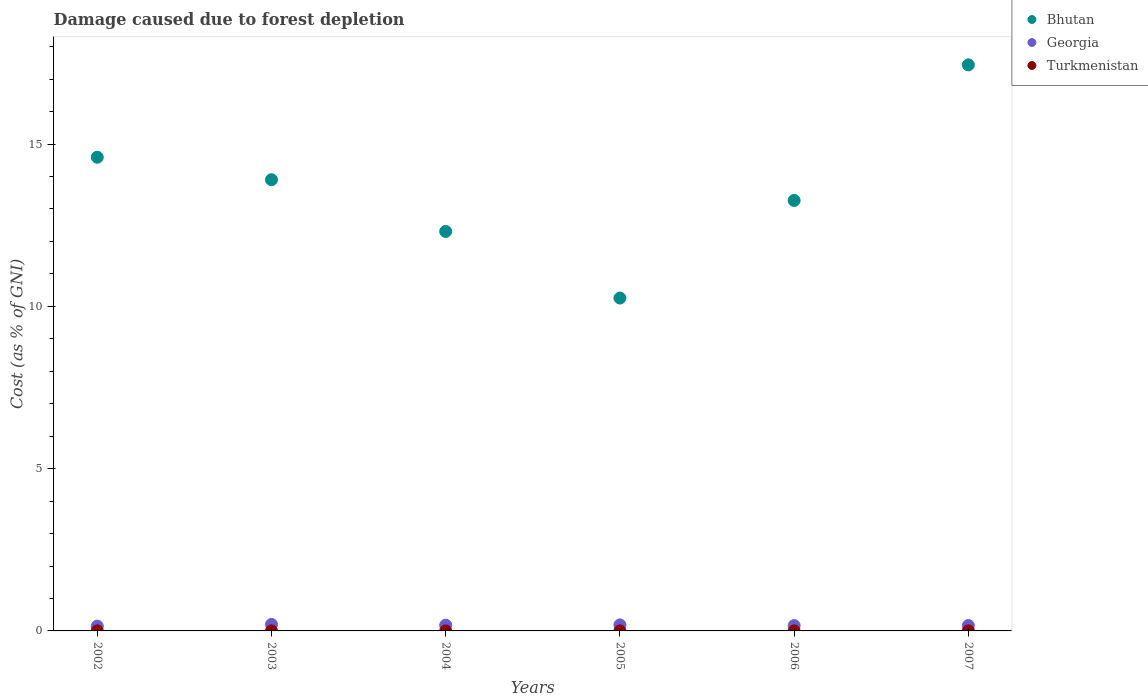How many different coloured dotlines are there?
Offer a terse response. 3. What is the cost of damage caused due to forest depletion in Georgia in 2005?
Keep it short and to the point. 0.19. Across all years, what is the maximum cost of damage caused due to forest depletion in Bhutan?
Ensure brevity in your answer.  17.44. Across all years, what is the minimum cost of damage caused due to forest depletion in Georgia?
Make the answer very short. 0.15. In which year was the cost of damage caused due to forest depletion in Turkmenistan maximum?
Your answer should be compact. 2006. What is the total cost of damage caused due to forest depletion in Georgia in the graph?
Provide a short and direct response. 1.04. What is the difference between the cost of damage caused due to forest depletion in Bhutan in 2003 and that in 2007?
Your response must be concise. -3.54. What is the difference between the cost of damage caused due to forest depletion in Turkmenistan in 2002 and the cost of damage caused due to forest depletion in Georgia in 2003?
Offer a terse response. -0.2. What is the average cost of damage caused due to forest depletion in Georgia per year?
Offer a terse response. 0.17. In the year 2002, what is the difference between the cost of damage caused due to forest depletion in Georgia and cost of damage caused due to forest depletion in Bhutan?
Your answer should be compact. -14.45. What is the ratio of the cost of damage caused due to forest depletion in Turkmenistan in 2002 to that in 2006?
Your answer should be very brief. 0.59. Is the difference between the cost of damage caused due to forest depletion in Georgia in 2003 and 2004 greater than the difference between the cost of damage caused due to forest depletion in Bhutan in 2003 and 2004?
Ensure brevity in your answer.  No. What is the difference between the highest and the second highest cost of damage caused due to forest depletion in Bhutan?
Your answer should be compact. 2.85. What is the difference between the highest and the lowest cost of damage caused due to forest depletion in Bhutan?
Offer a very short reply. 7.18. In how many years, is the cost of damage caused due to forest depletion in Turkmenistan greater than the average cost of damage caused due to forest depletion in Turkmenistan taken over all years?
Keep it short and to the point. 2. Does the cost of damage caused due to forest depletion in Bhutan monotonically increase over the years?
Make the answer very short. No. Is the cost of damage caused due to forest depletion in Georgia strictly greater than the cost of damage caused due to forest depletion in Turkmenistan over the years?
Give a very brief answer. Yes. How many dotlines are there?
Provide a succinct answer. 3. How many years are there in the graph?
Provide a succinct answer. 6. What is the difference between two consecutive major ticks on the Y-axis?
Give a very brief answer. 5. Are the values on the major ticks of Y-axis written in scientific E-notation?
Offer a terse response. No. Does the graph contain any zero values?
Your answer should be very brief. No. Does the graph contain grids?
Make the answer very short. No. How many legend labels are there?
Provide a short and direct response. 3. What is the title of the graph?
Provide a succinct answer. Damage caused due to forest depletion. Does "Cayman Islands" appear as one of the legend labels in the graph?
Provide a succinct answer. No. What is the label or title of the Y-axis?
Offer a very short reply. Cost (as % of GNI). What is the Cost (as % of GNI) of Bhutan in 2002?
Keep it short and to the point. 14.59. What is the Cost (as % of GNI) of Georgia in 2002?
Provide a short and direct response. 0.15. What is the Cost (as % of GNI) of Turkmenistan in 2002?
Offer a terse response. 0. What is the Cost (as % of GNI) of Bhutan in 2003?
Your answer should be compact. 13.9. What is the Cost (as % of GNI) of Georgia in 2003?
Keep it short and to the point. 0.2. What is the Cost (as % of GNI) in Turkmenistan in 2003?
Offer a terse response. 0. What is the Cost (as % of GNI) in Bhutan in 2004?
Ensure brevity in your answer.  12.31. What is the Cost (as % of GNI) in Georgia in 2004?
Provide a succinct answer. 0.18. What is the Cost (as % of GNI) of Turkmenistan in 2004?
Make the answer very short. 0. What is the Cost (as % of GNI) in Bhutan in 2005?
Your answer should be very brief. 10.26. What is the Cost (as % of GNI) of Georgia in 2005?
Offer a terse response. 0.19. What is the Cost (as % of GNI) of Turkmenistan in 2005?
Provide a short and direct response. 0. What is the Cost (as % of GNI) in Bhutan in 2006?
Offer a terse response. 13.26. What is the Cost (as % of GNI) of Georgia in 2006?
Your answer should be very brief. 0.16. What is the Cost (as % of GNI) in Turkmenistan in 2006?
Make the answer very short. 0. What is the Cost (as % of GNI) of Bhutan in 2007?
Provide a short and direct response. 17.44. What is the Cost (as % of GNI) of Georgia in 2007?
Offer a very short reply. 0.17. What is the Cost (as % of GNI) in Turkmenistan in 2007?
Your answer should be very brief. 0. Across all years, what is the maximum Cost (as % of GNI) of Bhutan?
Your answer should be very brief. 17.44. Across all years, what is the maximum Cost (as % of GNI) of Georgia?
Provide a succinct answer. 0.2. Across all years, what is the maximum Cost (as % of GNI) in Turkmenistan?
Provide a succinct answer. 0. Across all years, what is the minimum Cost (as % of GNI) of Bhutan?
Offer a terse response. 10.26. Across all years, what is the minimum Cost (as % of GNI) of Georgia?
Offer a terse response. 0.15. Across all years, what is the minimum Cost (as % of GNI) in Turkmenistan?
Your answer should be very brief. 0. What is the total Cost (as % of GNI) in Bhutan in the graph?
Provide a short and direct response. 81.76. What is the total Cost (as % of GNI) in Georgia in the graph?
Keep it short and to the point. 1.04. What is the total Cost (as % of GNI) of Turkmenistan in the graph?
Your response must be concise. 0.01. What is the difference between the Cost (as % of GNI) in Bhutan in 2002 and that in 2003?
Offer a very short reply. 0.69. What is the difference between the Cost (as % of GNI) of Georgia in 2002 and that in 2003?
Provide a succinct answer. -0.05. What is the difference between the Cost (as % of GNI) of Turkmenistan in 2002 and that in 2003?
Offer a very short reply. 0. What is the difference between the Cost (as % of GNI) of Bhutan in 2002 and that in 2004?
Give a very brief answer. 2.29. What is the difference between the Cost (as % of GNI) in Georgia in 2002 and that in 2004?
Ensure brevity in your answer.  -0.03. What is the difference between the Cost (as % of GNI) in Bhutan in 2002 and that in 2005?
Provide a succinct answer. 4.34. What is the difference between the Cost (as % of GNI) of Georgia in 2002 and that in 2005?
Your answer should be compact. -0.04. What is the difference between the Cost (as % of GNI) in Turkmenistan in 2002 and that in 2005?
Ensure brevity in your answer.  0. What is the difference between the Cost (as % of GNI) of Bhutan in 2002 and that in 2006?
Make the answer very short. 1.33. What is the difference between the Cost (as % of GNI) in Georgia in 2002 and that in 2006?
Your answer should be very brief. -0.02. What is the difference between the Cost (as % of GNI) of Turkmenistan in 2002 and that in 2006?
Keep it short and to the point. -0. What is the difference between the Cost (as % of GNI) in Bhutan in 2002 and that in 2007?
Ensure brevity in your answer.  -2.85. What is the difference between the Cost (as % of GNI) of Georgia in 2002 and that in 2007?
Offer a very short reply. -0.02. What is the difference between the Cost (as % of GNI) in Turkmenistan in 2002 and that in 2007?
Your answer should be very brief. -0. What is the difference between the Cost (as % of GNI) of Bhutan in 2003 and that in 2004?
Give a very brief answer. 1.59. What is the difference between the Cost (as % of GNI) of Georgia in 2003 and that in 2004?
Make the answer very short. 0.02. What is the difference between the Cost (as % of GNI) of Bhutan in 2003 and that in 2005?
Your answer should be compact. 3.65. What is the difference between the Cost (as % of GNI) in Georgia in 2003 and that in 2005?
Ensure brevity in your answer.  0.01. What is the difference between the Cost (as % of GNI) of Turkmenistan in 2003 and that in 2005?
Offer a terse response. 0. What is the difference between the Cost (as % of GNI) in Bhutan in 2003 and that in 2006?
Provide a succinct answer. 0.64. What is the difference between the Cost (as % of GNI) in Georgia in 2003 and that in 2006?
Provide a succinct answer. 0.04. What is the difference between the Cost (as % of GNI) of Turkmenistan in 2003 and that in 2006?
Your answer should be compact. -0. What is the difference between the Cost (as % of GNI) in Bhutan in 2003 and that in 2007?
Give a very brief answer. -3.54. What is the difference between the Cost (as % of GNI) in Georgia in 2003 and that in 2007?
Provide a short and direct response. 0.03. What is the difference between the Cost (as % of GNI) of Turkmenistan in 2003 and that in 2007?
Ensure brevity in your answer.  -0. What is the difference between the Cost (as % of GNI) of Bhutan in 2004 and that in 2005?
Offer a terse response. 2.05. What is the difference between the Cost (as % of GNI) of Georgia in 2004 and that in 2005?
Keep it short and to the point. -0.01. What is the difference between the Cost (as % of GNI) in Bhutan in 2004 and that in 2006?
Keep it short and to the point. -0.95. What is the difference between the Cost (as % of GNI) of Georgia in 2004 and that in 2006?
Provide a short and direct response. 0.01. What is the difference between the Cost (as % of GNI) in Turkmenistan in 2004 and that in 2006?
Keep it short and to the point. -0. What is the difference between the Cost (as % of GNI) in Bhutan in 2004 and that in 2007?
Offer a very short reply. -5.13. What is the difference between the Cost (as % of GNI) in Georgia in 2004 and that in 2007?
Your response must be concise. 0.01. What is the difference between the Cost (as % of GNI) of Turkmenistan in 2004 and that in 2007?
Your answer should be compact. -0. What is the difference between the Cost (as % of GNI) in Bhutan in 2005 and that in 2006?
Provide a short and direct response. -3.01. What is the difference between the Cost (as % of GNI) of Georgia in 2005 and that in 2006?
Ensure brevity in your answer.  0.02. What is the difference between the Cost (as % of GNI) in Turkmenistan in 2005 and that in 2006?
Provide a short and direct response. -0. What is the difference between the Cost (as % of GNI) in Bhutan in 2005 and that in 2007?
Give a very brief answer. -7.18. What is the difference between the Cost (as % of GNI) in Georgia in 2005 and that in 2007?
Provide a short and direct response. 0.02. What is the difference between the Cost (as % of GNI) of Turkmenistan in 2005 and that in 2007?
Give a very brief answer. -0. What is the difference between the Cost (as % of GNI) in Bhutan in 2006 and that in 2007?
Your answer should be very brief. -4.18. What is the difference between the Cost (as % of GNI) of Georgia in 2006 and that in 2007?
Provide a short and direct response. -0. What is the difference between the Cost (as % of GNI) in Bhutan in 2002 and the Cost (as % of GNI) in Georgia in 2003?
Your answer should be compact. 14.39. What is the difference between the Cost (as % of GNI) in Bhutan in 2002 and the Cost (as % of GNI) in Turkmenistan in 2003?
Make the answer very short. 14.59. What is the difference between the Cost (as % of GNI) of Georgia in 2002 and the Cost (as % of GNI) of Turkmenistan in 2003?
Your response must be concise. 0.15. What is the difference between the Cost (as % of GNI) of Bhutan in 2002 and the Cost (as % of GNI) of Georgia in 2004?
Ensure brevity in your answer.  14.42. What is the difference between the Cost (as % of GNI) of Bhutan in 2002 and the Cost (as % of GNI) of Turkmenistan in 2004?
Your answer should be compact. 14.59. What is the difference between the Cost (as % of GNI) in Georgia in 2002 and the Cost (as % of GNI) in Turkmenistan in 2004?
Your answer should be compact. 0.15. What is the difference between the Cost (as % of GNI) in Bhutan in 2002 and the Cost (as % of GNI) in Georgia in 2005?
Offer a very short reply. 14.41. What is the difference between the Cost (as % of GNI) in Bhutan in 2002 and the Cost (as % of GNI) in Turkmenistan in 2005?
Offer a very short reply. 14.59. What is the difference between the Cost (as % of GNI) of Georgia in 2002 and the Cost (as % of GNI) of Turkmenistan in 2005?
Your response must be concise. 0.15. What is the difference between the Cost (as % of GNI) in Bhutan in 2002 and the Cost (as % of GNI) in Georgia in 2006?
Give a very brief answer. 14.43. What is the difference between the Cost (as % of GNI) of Bhutan in 2002 and the Cost (as % of GNI) of Turkmenistan in 2006?
Keep it short and to the point. 14.59. What is the difference between the Cost (as % of GNI) in Georgia in 2002 and the Cost (as % of GNI) in Turkmenistan in 2006?
Your response must be concise. 0.15. What is the difference between the Cost (as % of GNI) of Bhutan in 2002 and the Cost (as % of GNI) of Georgia in 2007?
Offer a terse response. 14.43. What is the difference between the Cost (as % of GNI) in Bhutan in 2002 and the Cost (as % of GNI) in Turkmenistan in 2007?
Provide a succinct answer. 14.59. What is the difference between the Cost (as % of GNI) of Georgia in 2002 and the Cost (as % of GNI) of Turkmenistan in 2007?
Your answer should be very brief. 0.15. What is the difference between the Cost (as % of GNI) in Bhutan in 2003 and the Cost (as % of GNI) in Georgia in 2004?
Your answer should be very brief. 13.72. What is the difference between the Cost (as % of GNI) in Bhutan in 2003 and the Cost (as % of GNI) in Turkmenistan in 2004?
Offer a terse response. 13.9. What is the difference between the Cost (as % of GNI) in Bhutan in 2003 and the Cost (as % of GNI) in Georgia in 2005?
Make the answer very short. 13.72. What is the difference between the Cost (as % of GNI) in Bhutan in 2003 and the Cost (as % of GNI) in Turkmenistan in 2005?
Your answer should be very brief. 13.9. What is the difference between the Cost (as % of GNI) of Georgia in 2003 and the Cost (as % of GNI) of Turkmenistan in 2005?
Your response must be concise. 0.2. What is the difference between the Cost (as % of GNI) in Bhutan in 2003 and the Cost (as % of GNI) in Georgia in 2006?
Provide a succinct answer. 13.74. What is the difference between the Cost (as % of GNI) in Bhutan in 2003 and the Cost (as % of GNI) in Turkmenistan in 2006?
Offer a terse response. 13.9. What is the difference between the Cost (as % of GNI) in Georgia in 2003 and the Cost (as % of GNI) in Turkmenistan in 2006?
Give a very brief answer. 0.2. What is the difference between the Cost (as % of GNI) of Bhutan in 2003 and the Cost (as % of GNI) of Georgia in 2007?
Give a very brief answer. 13.74. What is the difference between the Cost (as % of GNI) of Bhutan in 2003 and the Cost (as % of GNI) of Turkmenistan in 2007?
Your response must be concise. 13.9. What is the difference between the Cost (as % of GNI) of Georgia in 2003 and the Cost (as % of GNI) of Turkmenistan in 2007?
Your answer should be compact. 0.2. What is the difference between the Cost (as % of GNI) in Bhutan in 2004 and the Cost (as % of GNI) in Georgia in 2005?
Provide a short and direct response. 12.12. What is the difference between the Cost (as % of GNI) of Bhutan in 2004 and the Cost (as % of GNI) of Turkmenistan in 2005?
Ensure brevity in your answer.  12.31. What is the difference between the Cost (as % of GNI) of Georgia in 2004 and the Cost (as % of GNI) of Turkmenistan in 2005?
Offer a terse response. 0.18. What is the difference between the Cost (as % of GNI) of Bhutan in 2004 and the Cost (as % of GNI) of Georgia in 2006?
Provide a short and direct response. 12.14. What is the difference between the Cost (as % of GNI) of Bhutan in 2004 and the Cost (as % of GNI) of Turkmenistan in 2006?
Ensure brevity in your answer.  12.31. What is the difference between the Cost (as % of GNI) in Georgia in 2004 and the Cost (as % of GNI) in Turkmenistan in 2006?
Provide a succinct answer. 0.18. What is the difference between the Cost (as % of GNI) of Bhutan in 2004 and the Cost (as % of GNI) of Georgia in 2007?
Your response must be concise. 12.14. What is the difference between the Cost (as % of GNI) in Bhutan in 2004 and the Cost (as % of GNI) in Turkmenistan in 2007?
Your answer should be very brief. 12.31. What is the difference between the Cost (as % of GNI) in Georgia in 2004 and the Cost (as % of GNI) in Turkmenistan in 2007?
Your answer should be very brief. 0.18. What is the difference between the Cost (as % of GNI) of Bhutan in 2005 and the Cost (as % of GNI) of Georgia in 2006?
Offer a very short reply. 10.09. What is the difference between the Cost (as % of GNI) of Bhutan in 2005 and the Cost (as % of GNI) of Turkmenistan in 2006?
Your answer should be compact. 10.25. What is the difference between the Cost (as % of GNI) of Georgia in 2005 and the Cost (as % of GNI) of Turkmenistan in 2006?
Ensure brevity in your answer.  0.18. What is the difference between the Cost (as % of GNI) of Bhutan in 2005 and the Cost (as % of GNI) of Georgia in 2007?
Offer a very short reply. 10.09. What is the difference between the Cost (as % of GNI) in Bhutan in 2005 and the Cost (as % of GNI) in Turkmenistan in 2007?
Provide a succinct answer. 10.25. What is the difference between the Cost (as % of GNI) of Georgia in 2005 and the Cost (as % of GNI) of Turkmenistan in 2007?
Provide a short and direct response. 0.18. What is the difference between the Cost (as % of GNI) in Bhutan in 2006 and the Cost (as % of GNI) in Georgia in 2007?
Offer a terse response. 13.1. What is the difference between the Cost (as % of GNI) of Bhutan in 2006 and the Cost (as % of GNI) of Turkmenistan in 2007?
Offer a terse response. 13.26. What is the difference between the Cost (as % of GNI) of Georgia in 2006 and the Cost (as % of GNI) of Turkmenistan in 2007?
Ensure brevity in your answer.  0.16. What is the average Cost (as % of GNI) of Bhutan per year?
Offer a terse response. 13.63. What is the average Cost (as % of GNI) of Georgia per year?
Your response must be concise. 0.17. What is the average Cost (as % of GNI) in Turkmenistan per year?
Provide a succinct answer. 0. In the year 2002, what is the difference between the Cost (as % of GNI) in Bhutan and Cost (as % of GNI) in Georgia?
Ensure brevity in your answer.  14.45. In the year 2002, what is the difference between the Cost (as % of GNI) in Bhutan and Cost (as % of GNI) in Turkmenistan?
Ensure brevity in your answer.  14.59. In the year 2002, what is the difference between the Cost (as % of GNI) in Georgia and Cost (as % of GNI) in Turkmenistan?
Give a very brief answer. 0.15. In the year 2003, what is the difference between the Cost (as % of GNI) of Bhutan and Cost (as % of GNI) of Georgia?
Your response must be concise. 13.7. In the year 2003, what is the difference between the Cost (as % of GNI) in Bhutan and Cost (as % of GNI) in Turkmenistan?
Provide a short and direct response. 13.9. In the year 2003, what is the difference between the Cost (as % of GNI) of Georgia and Cost (as % of GNI) of Turkmenistan?
Ensure brevity in your answer.  0.2. In the year 2004, what is the difference between the Cost (as % of GNI) of Bhutan and Cost (as % of GNI) of Georgia?
Make the answer very short. 12.13. In the year 2004, what is the difference between the Cost (as % of GNI) in Bhutan and Cost (as % of GNI) in Turkmenistan?
Ensure brevity in your answer.  12.31. In the year 2004, what is the difference between the Cost (as % of GNI) in Georgia and Cost (as % of GNI) in Turkmenistan?
Keep it short and to the point. 0.18. In the year 2005, what is the difference between the Cost (as % of GNI) in Bhutan and Cost (as % of GNI) in Georgia?
Give a very brief answer. 10.07. In the year 2005, what is the difference between the Cost (as % of GNI) of Bhutan and Cost (as % of GNI) of Turkmenistan?
Your response must be concise. 10.26. In the year 2005, what is the difference between the Cost (as % of GNI) of Georgia and Cost (as % of GNI) of Turkmenistan?
Keep it short and to the point. 0.19. In the year 2006, what is the difference between the Cost (as % of GNI) in Bhutan and Cost (as % of GNI) in Georgia?
Ensure brevity in your answer.  13.1. In the year 2006, what is the difference between the Cost (as % of GNI) of Bhutan and Cost (as % of GNI) of Turkmenistan?
Keep it short and to the point. 13.26. In the year 2006, what is the difference between the Cost (as % of GNI) in Georgia and Cost (as % of GNI) in Turkmenistan?
Offer a very short reply. 0.16. In the year 2007, what is the difference between the Cost (as % of GNI) in Bhutan and Cost (as % of GNI) in Georgia?
Provide a short and direct response. 17.27. In the year 2007, what is the difference between the Cost (as % of GNI) of Bhutan and Cost (as % of GNI) of Turkmenistan?
Provide a short and direct response. 17.44. In the year 2007, what is the difference between the Cost (as % of GNI) of Georgia and Cost (as % of GNI) of Turkmenistan?
Your answer should be compact. 0.16. What is the ratio of the Cost (as % of GNI) in Bhutan in 2002 to that in 2003?
Make the answer very short. 1.05. What is the ratio of the Cost (as % of GNI) of Georgia in 2002 to that in 2003?
Provide a succinct answer. 0.74. What is the ratio of the Cost (as % of GNI) in Turkmenistan in 2002 to that in 2003?
Your response must be concise. 1.02. What is the ratio of the Cost (as % of GNI) of Bhutan in 2002 to that in 2004?
Make the answer very short. 1.19. What is the ratio of the Cost (as % of GNI) of Georgia in 2002 to that in 2004?
Offer a terse response. 0.83. What is the ratio of the Cost (as % of GNI) of Turkmenistan in 2002 to that in 2004?
Offer a very short reply. 1.33. What is the ratio of the Cost (as % of GNI) of Bhutan in 2002 to that in 2005?
Provide a short and direct response. 1.42. What is the ratio of the Cost (as % of GNI) of Georgia in 2002 to that in 2005?
Your answer should be compact. 0.8. What is the ratio of the Cost (as % of GNI) in Turkmenistan in 2002 to that in 2005?
Ensure brevity in your answer.  1.41. What is the ratio of the Cost (as % of GNI) of Bhutan in 2002 to that in 2006?
Give a very brief answer. 1.1. What is the ratio of the Cost (as % of GNI) of Georgia in 2002 to that in 2006?
Provide a succinct answer. 0.91. What is the ratio of the Cost (as % of GNI) of Turkmenistan in 2002 to that in 2006?
Provide a succinct answer. 0.59. What is the ratio of the Cost (as % of GNI) of Bhutan in 2002 to that in 2007?
Your answer should be compact. 0.84. What is the ratio of the Cost (as % of GNI) in Georgia in 2002 to that in 2007?
Make the answer very short. 0.89. What is the ratio of the Cost (as % of GNI) of Turkmenistan in 2002 to that in 2007?
Provide a short and direct response. 0.63. What is the ratio of the Cost (as % of GNI) in Bhutan in 2003 to that in 2004?
Your answer should be very brief. 1.13. What is the ratio of the Cost (as % of GNI) of Georgia in 2003 to that in 2004?
Your answer should be very brief. 1.13. What is the ratio of the Cost (as % of GNI) in Turkmenistan in 2003 to that in 2004?
Provide a short and direct response. 1.3. What is the ratio of the Cost (as % of GNI) of Bhutan in 2003 to that in 2005?
Make the answer very short. 1.36. What is the ratio of the Cost (as % of GNI) in Georgia in 2003 to that in 2005?
Your answer should be compact. 1.08. What is the ratio of the Cost (as % of GNI) of Turkmenistan in 2003 to that in 2005?
Give a very brief answer. 1.37. What is the ratio of the Cost (as % of GNI) of Bhutan in 2003 to that in 2006?
Offer a very short reply. 1.05. What is the ratio of the Cost (as % of GNI) in Georgia in 2003 to that in 2006?
Ensure brevity in your answer.  1.23. What is the ratio of the Cost (as % of GNI) in Turkmenistan in 2003 to that in 2006?
Provide a short and direct response. 0.58. What is the ratio of the Cost (as % of GNI) of Bhutan in 2003 to that in 2007?
Offer a terse response. 0.8. What is the ratio of the Cost (as % of GNI) in Georgia in 2003 to that in 2007?
Offer a very short reply. 1.21. What is the ratio of the Cost (as % of GNI) in Turkmenistan in 2003 to that in 2007?
Give a very brief answer. 0.62. What is the ratio of the Cost (as % of GNI) in Bhutan in 2004 to that in 2005?
Offer a very short reply. 1.2. What is the ratio of the Cost (as % of GNI) of Georgia in 2004 to that in 2005?
Your answer should be compact. 0.96. What is the ratio of the Cost (as % of GNI) in Turkmenistan in 2004 to that in 2005?
Offer a very short reply. 1.06. What is the ratio of the Cost (as % of GNI) of Bhutan in 2004 to that in 2006?
Give a very brief answer. 0.93. What is the ratio of the Cost (as % of GNI) of Georgia in 2004 to that in 2006?
Offer a very short reply. 1.09. What is the ratio of the Cost (as % of GNI) of Turkmenistan in 2004 to that in 2006?
Ensure brevity in your answer.  0.45. What is the ratio of the Cost (as % of GNI) in Bhutan in 2004 to that in 2007?
Your response must be concise. 0.71. What is the ratio of the Cost (as % of GNI) of Georgia in 2004 to that in 2007?
Your response must be concise. 1.07. What is the ratio of the Cost (as % of GNI) in Turkmenistan in 2004 to that in 2007?
Keep it short and to the point. 0.48. What is the ratio of the Cost (as % of GNI) of Bhutan in 2005 to that in 2006?
Offer a terse response. 0.77. What is the ratio of the Cost (as % of GNI) of Georgia in 2005 to that in 2006?
Make the answer very short. 1.13. What is the ratio of the Cost (as % of GNI) of Turkmenistan in 2005 to that in 2006?
Your answer should be very brief. 0.42. What is the ratio of the Cost (as % of GNI) of Bhutan in 2005 to that in 2007?
Provide a short and direct response. 0.59. What is the ratio of the Cost (as % of GNI) of Georgia in 2005 to that in 2007?
Give a very brief answer. 1.12. What is the ratio of the Cost (as % of GNI) in Turkmenistan in 2005 to that in 2007?
Provide a short and direct response. 0.45. What is the ratio of the Cost (as % of GNI) in Bhutan in 2006 to that in 2007?
Offer a terse response. 0.76. What is the ratio of the Cost (as % of GNI) in Turkmenistan in 2006 to that in 2007?
Give a very brief answer. 1.07. What is the difference between the highest and the second highest Cost (as % of GNI) of Bhutan?
Your answer should be very brief. 2.85. What is the difference between the highest and the second highest Cost (as % of GNI) in Georgia?
Your response must be concise. 0.01. What is the difference between the highest and the second highest Cost (as % of GNI) of Turkmenistan?
Make the answer very short. 0. What is the difference between the highest and the lowest Cost (as % of GNI) of Bhutan?
Provide a succinct answer. 7.18. What is the difference between the highest and the lowest Cost (as % of GNI) of Georgia?
Give a very brief answer. 0.05. What is the difference between the highest and the lowest Cost (as % of GNI) in Turkmenistan?
Your answer should be compact. 0. 